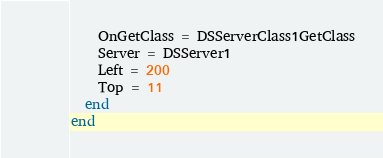Convert code to text. <code><loc_0><loc_0><loc_500><loc_500><_Pascal_>    OnGetClass = DSServerClass1GetClass
    Server = DSServer1
    Left = 200
    Top = 11
  end
end
</code> 